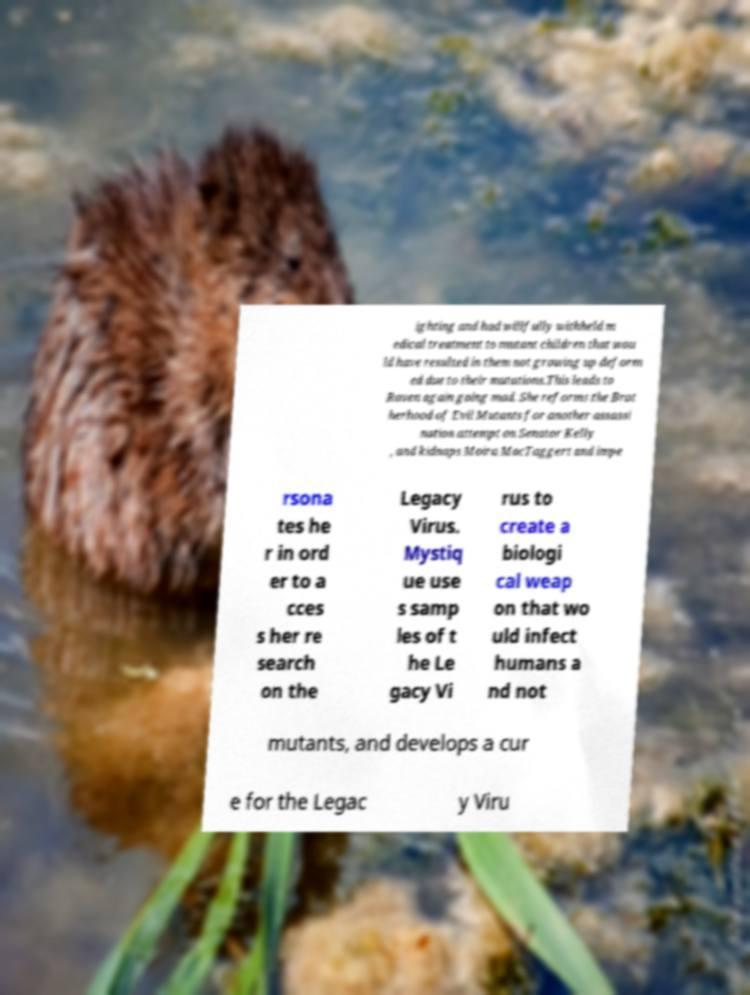What messages or text are displayed in this image? I need them in a readable, typed format. ighting and had willfully withheld m edical treatment to mutant children that wou ld have resulted in them not growing up deform ed due to their mutations.This leads to Raven again going mad. She reforms the Brot herhood of Evil Mutants for another assassi nation attempt on Senator Kelly , and kidnaps Moira MacTaggert and impe rsona tes he r in ord er to a cces s her re search on the Legacy Virus. Mystiq ue use s samp les of t he Le gacy Vi rus to create a biologi cal weap on that wo uld infect humans a nd not mutants, and develops a cur e for the Legac y Viru 